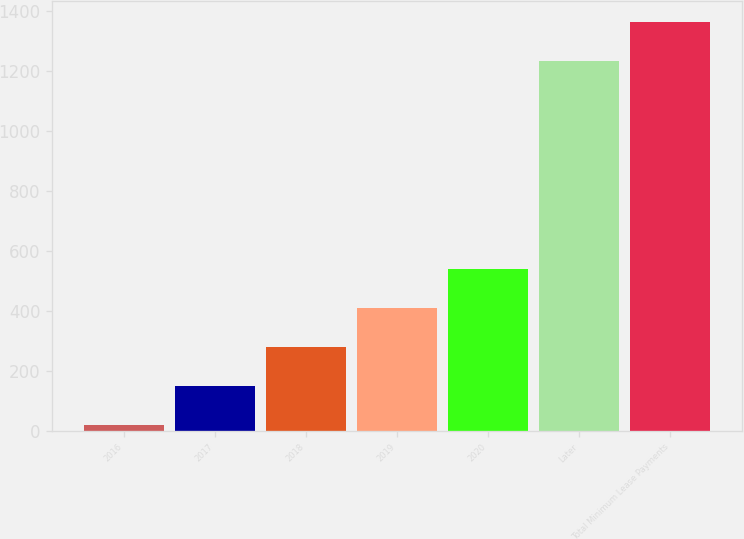Convert chart. <chart><loc_0><loc_0><loc_500><loc_500><bar_chart><fcel>2016<fcel>2017<fcel>2018<fcel>2019<fcel>2020<fcel>Later<fcel>Total Minimum Lease Payments<nl><fcel>18<fcel>148.6<fcel>279.2<fcel>409.8<fcel>540.4<fcel>1234<fcel>1364.6<nl></chart> 